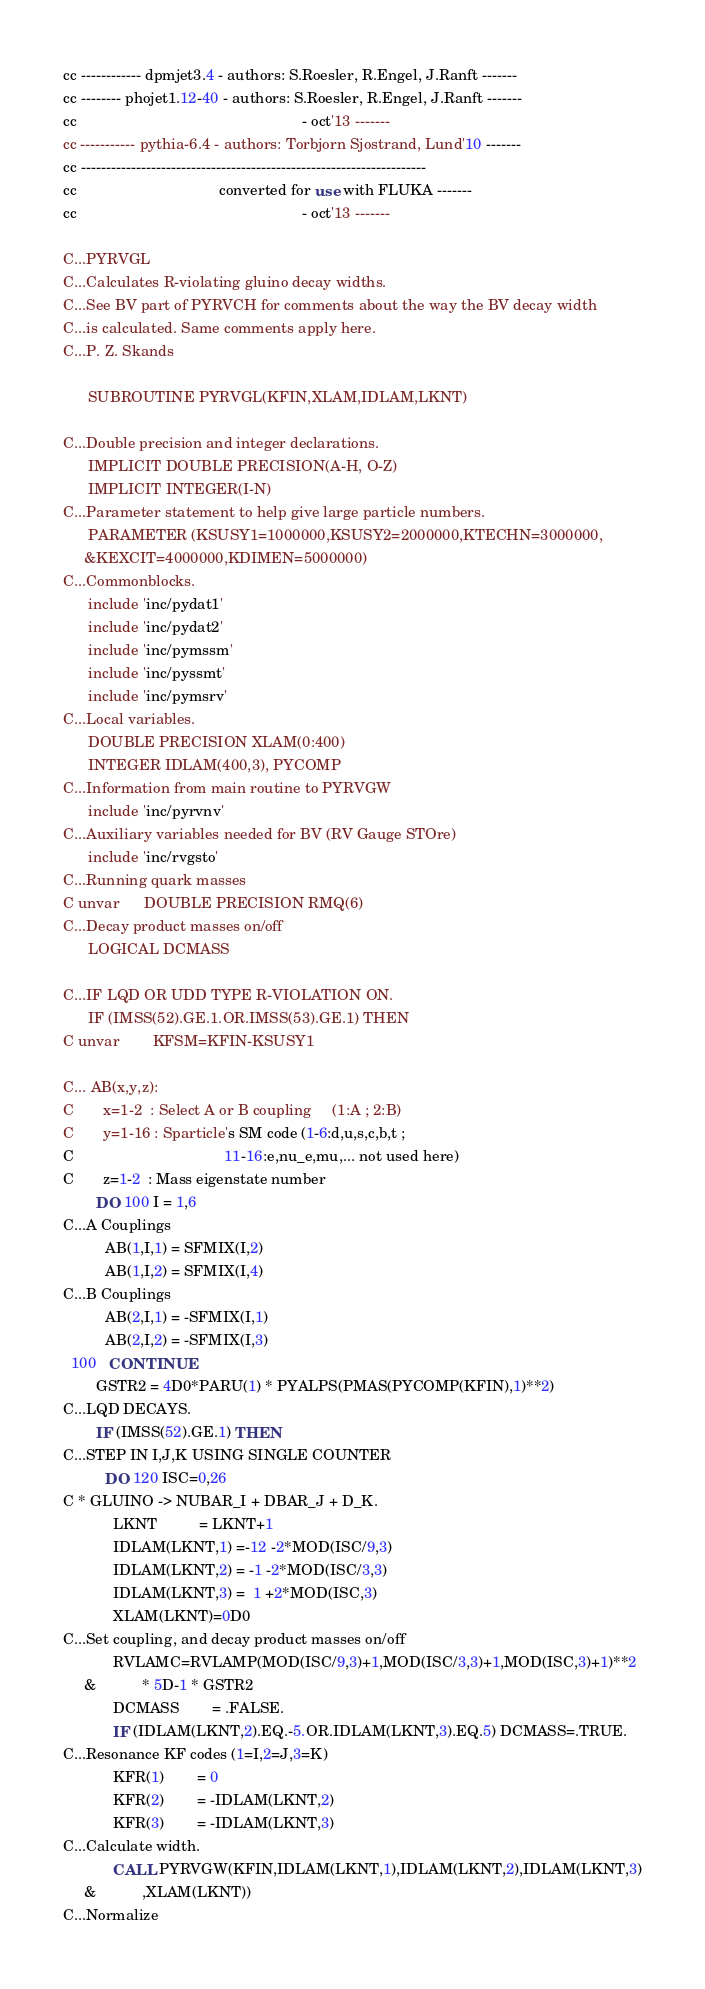<code> <loc_0><loc_0><loc_500><loc_500><_FORTRAN_>cc ------------ dpmjet3.4 - authors: S.Roesler, R.Engel, J.Ranft -------
cc -------- phojet1.12-40 - authors: S.Roesler, R.Engel, J.Ranft -------
cc                                                      - oct'13 -------
cc ----------- pythia-6.4 - authors: Torbjorn Sjostrand, Lund'10 -------
cc ---------------------------------------------------------------------
cc                                  converted for use with FLUKA -------
cc                                                      - oct'13 -------
 
C...PYRVGL
C...Calculates R-violating gluino decay widths.
C...See BV part of PYRVCH for comments about the way the BV decay width
C...is calculated. Same comments apply here.
C...P. Z. Skands
 
      SUBROUTINE PYRVGL(KFIN,XLAM,IDLAM,LKNT)
 
C...Double precision and integer declarations.
      IMPLICIT DOUBLE PRECISION(A-H, O-Z)
      IMPLICIT INTEGER(I-N)
C...Parameter statement to help give large particle numbers.
      PARAMETER (KSUSY1=1000000,KSUSY2=2000000,KTECHN=3000000,
     &KEXCIT=4000000,KDIMEN=5000000)
C...Commonblocks.
      include 'inc/pydat1'
      include 'inc/pydat2'
      include 'inc/pymssm'
      include 'inc/pyssmt'
      include 'inc/pymsrv'
C...Local variables.
      DOUBLE PRECISION XLAM(0:400)
      INTEGER IDLAM(400,3), PYCOMP
C...Information from main routine to PYRVGW
      include 'inc/pyrvnv'
C...Auxiliary variables needed for BV (RV Gauge STOre)
      include 'inc/rvgsto'
C...Running quark masses
C unvar      DOUBLE PRECISION RMQ(6)
C...Decay product masses on/off
      LOGICAL DCMASS
 
C...IF LQD OR UDD TYPE R-VIOLATION ON.
      IF (IMSS(52).GE.1.OR.IMSS(53).GE.1) THEN
C unvar        KFSM=KFIN-KSUSY1
 
C... AB(x,y,z):
C       x=1-2  : Select A or B coupling     (1:A ; 2:B)
C       y=1-16 : Sparticle's SM code (1-6:d,u,s,c,b,t ;
C                                    11-16:e,nu_e,mu,... not used here)
C       z=1-2  : Mass eigenstate number
        DO 100 I = 1,6
C...A Couplings
          AB(1,I,1) = SFMIX(I,2)
          AB(1,I,2) = SFMIX(I,4)
C...B Couplings
          AB(2,I,1) = -SFMIX(I,1)
          AB(2,I,2) = -SFMIX(I,3)
  100   CONTINUE
        GSTR2 = 4D0*PARU(1) * PYALPS(PMAS(PYCOMP(KFIN),1)**2)
C...LQD DECAYS.
        IF (IMSS(52).GE.1) THEN
C...STEP IN I,J,K USING SINGLE COUNTER
          DO 120 ISC=0,26
C * GLUINO -> NUBAR_I + DBAR_J + D_K.
            LKNT          = LKNT+1
            IDLAM(LKNT,1) =-12 -2*MOD(ISC/9,3)
            IDLAM(LKNT,2) = -1 -2*MOD(ISC/3,3)
            IDLAM(LKNT,3) =  1 +2*MOD(ISC,3)
            XLAM(LKNT)=0D0
C...Set coupling, and decay product masses on/off
            RVLAMC=RVLAMP(MOD(ISC/9,3)+1,MOD(ISC/3,3)+1,MOD(ISC,3)+1)**2
     &           * 5D-1 * GSTR2
            DCMASS        = .FALSE.
            IF (IDLAM(LKNT,2).EQ.-5.OR.IDLAM(LKNT,3).EQ.5) DCMASS=.TRUE.
C...Resonance KF codes (1=I,2=J,3=K)
            KFR(1)        = 0
            KFR(2)        = -IDLAM(LKNT,2)
            KFR(3)        = -IDLAM(LKNT,3)
C...Calculate width.
            CALL PYRVGW(KFIN,IDLAM(LKNT,1),IDLAM(LKNT,2),IDLAM(LKNT,3)
     &           ,XLAM(LKNT))
C...Normalize</code> 